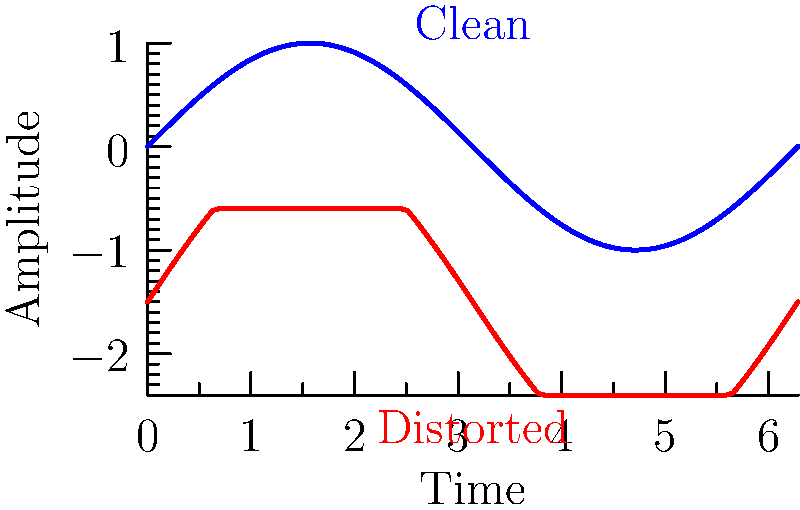Looking at the waveforms of clean and distorted guitar tones, what is the primary difference in the shape of the distorted waveform compared to the clean one? To analyze the difference between clean and distorted guitar tones, let's examine the waveforms step-by-step:

1. Clean guitar waveform (blue):
   - Smooth, sinusoidal shape
   - Rounded peaks and troughs
   - Consistent amplitude throughout the cycle

2. Distorted guitar waveform (red):
   - Flattened peaks and troughs
   - More abrupt transitions between positive and negative values
   - Compressed amplitude range

3. Main differences:
   - The distorted waveform has a more "square" appearance
   - Peaks and troughs are clipped or flattened
   - Transitions between positive and negative values are steeper

4. Cause of distortion:
   - Overdriving the amplifier or using distortion effects
   - Introduces harmonic content and compression

5. Effect on sound:
   - Adds richness and complexity to the tone
   - Creates a more aggressive, sustained sound typical in rock music

The primary difference is the flattening or clipping of the waveform's peaks and troughs in the distorted signal, resulting in a more square-like shape compared to the smooth, sinusoidal clean signal.
Answer: Flattened (clipped) peaks and troughs 